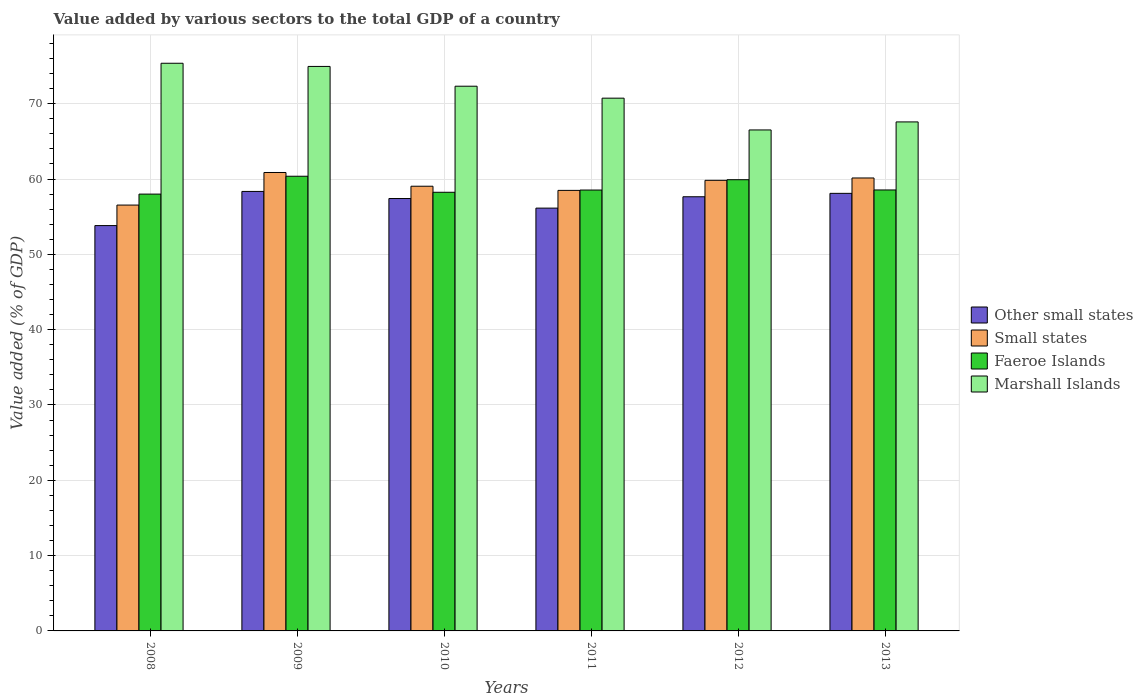How many groups of bars are there?
Ensure brevity in your answer.  6. Are the number of bars per tick equal to the number of legend labels?
Your response must be concise. Yes. Are the number of bars on each tick of the X-axis equal?
Keep it short and to the point. Yes. What is the label of the 1st group of bars from the left?
Ensure brevity in your answer.  2008. What is the value added by various sectors to the total GDP in Marshall Islands in 2008?
Your response must be concise. 75.37. Across all years, what is the maximum value added by various sectors to the total GDP in Marshall Islands?
Offer a very short reply. 75.37. Across all years, what is the minimum value added by various sectors to the total GDP in Small states?
Your response must be concise. 56.54. In which year was the value added by various sectors to the total GDP in Faeroe Islands maximum?
Make the answer very short. 2009. What is the total value added by various sectors to the total GDP in Marshall Islands in the graph?
Keep it short and to the point. 427.5. What is the difference between the value added by various sectors to the total GDP in Other small states in 2008 and that in 2009?
Make the answer very short. -4.54. What is the difference between the value added by various sectors to the total GDP in Marshall Islands in 2010 and the value added by various sectors to the total GDP in Small states in 2013?
Keep it short and to the point. 12.18. What is the average value added by various sectors to the total GDP in Faeroe Islands per year?
Keep it short and to the point. 58.94. In the year 2013, what is the difference between the value added by various sectors to the total GDP in Marshall Islands and value added by various sectors to the total GDP in Other small states?
Offer a terse response. 9.49. What is the ratio of the value added by various sectors to the total GDP in Faeroe Islands in 2012 to that in 2013?
Your answer should be compact. 1.02. Is the value added by various sectors to the total GDP in Other small states in 2010 less than that in 2012?
Give a very brief answer. Yes. Is the difference between the value added by various sectors to the total GDP in Marshall Islands in 2008 and 2011 greater than the difference between the value added by various sectors to the total GDP in Other small states in 2008 and 2011?
Provide a short and direct response. Yes. What is the difference between the highest and the second highest value added by various sectors to the total GDP in Faeroe Islands?
Provide a succinct answer. 0.46. What is the difference between the highest and the lowest value added by various sectors to the total GDP in Faeroe Islands?
Ensure brevity in your answer.  2.37. Is the sum of the value added by various sectors to the total GDP in Marshall Islands in 2012 and 2013 greater than the maximum value added by various sectors to the total GDP in Faeroe Islands across all years?
Provide a short and direct response. Yes. What does the 3rd bar from the left in 2011 represents?
Your answer should be compact. Faeroe Islands. What does the 4th bar from the right in 2013 represents?
Your answer should be compact. Other small states. Is it the case that in every year, the sum of the value added by various sectors to the total GDP in Marshall Islands and value added by various sectors to the total GDP in Small states is greater than the value added by various sectors to the total GDP in Faeroe Islands?
Offer a terse response. Yes. How many bars are there?
Give a very brief answer. 24. Are all the bars in the graph horizontal?
Offer a very short reply. No. How many years are there in the graph?
Offer a terse response. 6. What is the difference between two consecutive major ticks on the Y-axis?
Your answer should be compact. 10. Are the values on the major ticks of Y-axis written in scientific E-notation?
Your response must be concise. No. How are the legend labels stacked?
Give a very brief answer. Vertical. What is the title of the graph?
Offer a terse response. Value added by various sectors to the total GDP of a country. What is the label or title of the X-axis?
Your answer should be very brief. Years. What is the label or title of the Y-axis?
Offer a terse response. Value added (% of GDP). What is the Value added (% of GDP) in Other small states in 2008?
Your answer should be compact. 53.82. What is the Value added (% of GDP) in Small states in 2008?
Provide a short and direct response. 56.54. What is the Value added (% of GDP) of Faeroe Islands in 2008?
Offer a very short reply. 58. What is the Value added (% of GDP) of Marshall Islands in 2008?
Your response must be concise. 75.37. What is the Value added (% of GDP) in Other small states in 2009?
Make the answer very short. 58.36. What is the Value added (% of GDP) in Small states in 2009?
Keep it short and to the point. 60.87. What is the Value added (% of GDP) of Faeroe Islands in 2009?
Ensure brevity in your answer.  60.37. What is the Value added (% of GDP) in Marshall Islands in 2009?
Give a very brief answer. 74.95. What is the Value added (% of GDP) of Other small states in 2010?
Offer a terse response. 57.41. What is the Value added (% of GDP) in Small states in 2010?
Ensure brevity in your answer.  59.05. What is the Value added (% of GDP) in Faeroe Islands in 2010?
Provide a short and direct response. 58.24. What is the Value added (% of GDP) of Marshall Islands in 2010?
Give a very brief answer. 72.33. What is the Value added (% of GDP) of Other small states in 2011?
Provide a succinct answer. 56.14. What is the Value added (% of GDP) of Small states in 2011?
Keep it short and to the point. 58.49. What is the Value added (% of GDP) in Faeroe Islands in 2011?
Provide a succinct answer. 58.54. What is the Value added (% of GDP) of Marshall Islands in 2011?
Provide a short and direct response. 70.74. What is the Value added (% of GDP) in Other small states in 2012?
Make the answer very short. 57.65. What is the Value added (% of GDP) in Small states in 2012?
Make the answer very short. 59.83. What is the Value added (% of GDP) of Faeroe Islands in 2012?
Your answer should be very brief. 59.91. What is the Value added (% of GDP) in Marshall Islands in 2012?
Make the answer very short. 66.52. What is the Value added (% of GDP) in Other small states in 2013?
Your answer should be very brief. 58.1. What is the Value added (% of GDP) in Small states in 2013?
Make the answer very short. 60.14. What is the Value added (% of GDP) in Faeroe Islands in 2013?
Your answer should be compact. 58.55. What is the Value added (% of GDP) in Marshall Islands in 2013?
Provide a succinct answer. 67.59. Across all years, what is the maximum Value added (% of GDP) of Other small states?
Your answer should be compact. 58.36. Across all years, what is the maximum Value added (% of GDP) of Small states?
Offer a very short reply. 60.87. Across all years, what is the maximum Value added (% of GDP) in Faeroe Islands?
Give a very brief answer. 60.37. Across all years, what is the maximum Value added (% of GDP) of Marshall Islands?
Make the answer very short. 75.37. Across all years, what is the minimum Value added (% of GDP) of Other small states?
Your answer should be compact. 53.82. Across all years, what is the minimum Value added (% of GDP) in Small states?
Offer a very short reply. 56.54. Across all years, what is the minimum Value added (% of GDP) in Faeroe Islands?
Your response must be concise. 58. Across all years, what is the minimum Value added (% of GDP) in Marshall Islands?
Your response must be concise. 66.52. What is the total Value added (% of GDP) in Other small states in the graph?
Your answer should be very brief. 341.48. What is the total Value added (% of GDP) in Small states in the graph?
Offer a very short reply. 354.93. What is the total Value added (% of GDP) in Faeroe Islands in the graph?
Provide a succinct answer. 353.62. What is the total Value added (% of GDP) of Marshall Islands in the graph?
Give a very brief answer. 427.5. What is the difference between the Value added (% of GDP) of Other small states in 2008 and that in 2009?
Your answer should be very brief. -4.54. What is the difference between the Value added (% of GDP) of Small states in 2008 and that in 2009?
Make the answer very short. -4.33. What is the difference between the Value added (% of GDP) of Faeroe Islands in 2008 and that in 2009?
Offer a terse response. -2.37. What is the difference between the Value added (% of GDP) of Marshall Islands in 2008 and that in 2009?
Your answer should be compact. 0.42. What is the difference between the Value added (% of GDP) in Other small states in 2008 and that in 2010?
Your answer should be very brief. -3.59. What is the difference between the Value added (% of GDP) in Small states in 2008 and that in 2010?
Your response must be concise. -2.5. What is the difference between the Value added (% of GDP) in Faeroe Islands in 2008 and that in 2010?
Offer a terse response. -0.24. What is the difference between the Value added (% of GDP) of Marshall Islands in 2008 and that in 2010?
Make the answer very short. 3.05. What is the difference between the Value added (% of GDP) of Other small states in 2008 and that in 2011?
Keep it short and to the point. -2.32. What is the difference between the Value added (% of GDP) of Small states in 2008 and that in 2011?
Your answer should be compact. -1.95. What is the difference between the Value added (% of GDP) of Faeroe Islands in 2008 and that in 2011?
Keep it short and to the point. -0.54. What is the difference between the Value added (% of GDP) of Marshall Islands in 2008 and that in 2011?
Your response must be concise. 4.63. What is the difference between the Value added (% of GDP) in Other small states in 2008 and that in 2012?
Provide a short and direct response. -3.83. What is the difference between the Value added (% of GDP) in Small states in 2008 and that in 2012?
Ensure brevity in your answer.  -3.29. What is the difference between the Value added (% of GDP) of Faeroe Islands in 2008 and that in 2012?
Ensure brevity in your answer.  -1.91. What is the difference between the Value added (% of GDP) in Marshall Islands in 2008 and that in 2012?
Provide a short and direct response. 8.86. What is the difference between the Value added (% of GDP) of Other small states in 2008 and that in 2013?
Ensure brevity in your answer.  -4.28. What is the difference between the Value added (% of GDP) of Small states in 2008 and that in 2013?
Your answer should be very brief. -3.6. What is the difference between the Value added (% of GDP) in Faeroe Islands in 2008 and that in 2013?
Make the answer very short. -0.55. What is the difference between the Value added (% of GDP) of Marshall Islands in 2008 and that in 2013?
Provide a succinct answer. 7.79. What is the difference between the Value added (% of GDP) in Other small states in 2009 and that in 2010?
Offer a very short reply. 0.94. What is the difference between the Value added (% of GDP) in Small states in 2009 and that in 2010?
Offer a terse response. 1.82. What is the difference between the Value added (% of GDP) in Faeroe Islands in 2009 and that in 2010?
Offer a terse response. 2.13. What is the difference between the Value added (% of GDP) of Marshall Islands in 2009 and that in 2010?
Provide a succinct answer. 2.63. What is the difference between the Value added (% of GDP) of Other small states in 2009 and that in 2011?
Give a very brief answer. 2.21. What is the difference between the Value added (% of GDP) in Small states in 2009 and that in 2011?
Your response must be concise. 2.38. What is the difference between the Value added (% of GDP) in Faeroe Islands in 2009 and that in 2011?
Ensure brevity in your answer.  1.83. What is the difference between the Value added (% of GDP) in Marshall Islands in 2009 and that in 2011?
Your answer should be compact. 4.21. What is the difference between the Value added (% of GDP) in Other small states in 2009 and that in 2012?
Offer a terse response. 0.71. What is the difference between the Value added (% of GDP) of Small states in 2009 and that in 2012?
Your answer should be very brief. 1.04. What is the difference between the Value added (% of GDP) of Faeroe Islands in 2009 and that in 2012?
Your response must be concise. 0.46. What is the difference between the Value added (% of GDP) in Marshall Islands in 2009 and that in 2012?
Make the answer very short. 8.43. What is the difference between the Value added (% of GDP) in Other small states in 2009 and that in 2013?
Your answer should be very brief. 0.25. What is the difference between the Value added (% of GDP) in Small states in 2009 and that in 2013?
Offer a very short reply. 0.73. What is the difference between the Value added (% of GDP) of Faeroe Islands in 2009 and that in 2013?
Your answer should be compact. 1.82. What is the difference between the Value added (% of GDP) of Marshall Islands in 2009 and that in 2013?
Your answer should be very brief. 7.37. What is the difference between the Value added (% of GDP) of Other small states in 2010 and that in 2011?
Your answer should be compact. 1.27. What is the difference between the Value added (% of GDP) of Small states in 2010 and that in 2011?
Provide a succinct answer. 0.55. What is the difference between the Value added (% of GDP) in Faeroe Islands in 2010 and that in 2011?
Your answer should be very brief. -0.3. What is the difference between the Value added (% of GDP) of Marshall Islands in 2010 and that in 2011?
Your answer should be very brief. 1.59. What is the difference between the Value added (% of GDP) in Other small states in 2010 and that in 2012?
Offer a terse response. -0.23. What is the difference between the Value added (% of GDP) of Small states in 2010 and that in 2012?
Ensure brevity in your answer.  -0.78. What is the difference between the Value added (% of GDP) in Faeroe Islands in 2010 and that in 2012?
Provide a short and direct response. -1.67. What is the difference between the Value added (% of GDP) of Marshall Islands in 2010 and that in 2012?
Offer a very short reply. 5.81. What is the difference between the Value added (% of GDP) of Other small states in 2010 and that in 2013?
Keep it short and to the point. -0.69. What is the difference between the Value added (% of GDP) of Small states in 2010 and that in 2013?
Ensure brevity in your answer.  -1.1. What is the difference between the Value added (% of GDP) of Faeroe Islands in 2010 and that in 2013?
Make the answer very short. -0.31. What is the difference between the Value added (% of GDP) of Marshall Islands in 2010 and that in 2013?
Offer a very short reply. 4.74. What is the difference between the Value added (% of GDP) of Other small states in 2011 and that in 2012?
Provide a succinct answer. -1.51. What is the difference between the Value added (% of GDP) in Small states in 2011 and that in 2012?
Keep it short and to the point. -1.34. What is the difference between the Value added (% of GDP) in Faeroe Islands in 2011 and that in 2012?
Provide a succinct answer. -1.37. What is the difference between the Value added (% of GDP) in Marshall Islands in 2011 and that in 2012?
Provide a succinct answer. 4.22. What is the difference between the Value added (% of GDP) of Other small states in 2011 and that in 2013?
Your answer should be very brief. -1.96. What is the difference between the Value added (% of GDP) in Small states in 2011 and that in 2013?
Ensure brevity in your answer.  -1.65. What is the difference between the Value added (% of GDP) of Faeroe Islands in 2011 and that in 2013?
Your answer should be compact. -0.01. What is the difference between the Value added (% of GDP) of Marshall Islands in 2011 and that in 2013?
Your answer should be compact. 3.15. What is the difference between the Value added (% of GDP) in Other small states in 2012 and that in 2013?
Your answer should be compact. -0.45. What is the difference between the Value added (% of GDP) of Small states in 2012 and that in 2013?
Your answer should be very brief. -0.31. What is the difference between the Value added (% of GDP) of Faeroe Islands in 2012 and that in 2013?
Offer a terse response. 1.36. What is the difference between the Value added (% of GDP) in Marshall Islands in 2012 and that in 2013?
Give a very brief answer. -1.07. What is the difference between the Value added (% of GDP) in Other small states in 2008 and the Value added (% of GDP) in Small states in 2009?
Keep it short and to the point. -7.05. What is the difference between the Value added (% of GDP) of Other small states in 2008 and the Value added (% of GDP) of Faeroe Islands in 2009?
Provide a short and direct response. -6.55. What is the difference between the Value added (% of GDP) in Other small states in 2008 and the Value added (% of GDP) in Marshall Islands in 2009?
Provide a short and direct response. -21.13. What is the difference between the Value added (% of GDP) in Small states in 2008 and the Value added (% of GDP) in Faeroe Islands in 2009?
Ensure brevity in your answer.  -3.83. What is the difference between the Value added (% of GDP) in Small states in 2008 and the Value added (% of GDP) in Marshall Islands in 2009?
Offer a terse response. -18.41. What is the difference between the Value added (% of GDP) in Faeroe Islands in 2008 and the Value added (% of GDP) in Marshall Islands in 2009?
Provide a short and direct response. -16.95. What is the difference between the Value added (% of GDP) of Other small states in 2008 and the Value added (% of GDP) of Small states in 2010?
Give a very brief answer. -5.23. What is the difference between the Value added (% of GDP) of Other small states in 2008 and the Value added (% of GDP) of Faeroe Islands in 2010?
Keep it short and to the point. -4.42. What is the difference between the Value added (% of GDP) in Other small states in 2008 and the Value added (% of GDP) in Marshall Islands in 2010?
Offer a very short reply. -18.51. What is the difference between the Value added (% of GDP) in Small states in 2008 and the Value added (% of GDP) in Faeroe Islands in 2010?
Give a very brief answer. -1.7. What is the difference between the Value added (% of GDP) of Small states in 2008 and the Value added (% of GDP) of Marshall Islands in 2010?
Offer a terse response. -15.78. What is the difference between the Value added (% of GDP) of Faeroe Islands in 2008 and the Value added (% of GDP) of Marshall Islands in 2010?
Keep it short and to the point. -14.32. What is the difference between the Value added (% of GDP) of Other small states in 2008 and the Value added (% of GDP) of Small states in 2011?
Offer a very short reply. -4.67. What is the difference between the Value added (% of GDP) of Other small states in 2008 and the Value added (% of GDP) of Faeroe Islands in 2011?
Offer a terse response. -4.72. What is the difference between the Value added (% of GDP) of Other small states in 2008 and the Value added (% of GDP) of Marshall Islands in 2011?
Your answer should be very brief. -16.92. What is the difference between the Value added (% of GDP) of Small states in 2008 and the Value added (% of GDP) of Faeroe Islands in 2011?
Give a very brief answer. -2. What is the difference between the Value added (% of GDP) in Small states in 2008 and the Value added (% of GDP) in Marshall Islands in 2011?
Keep it short and to the point. -14.2. What is the difference between the Value added (% of GDP) in Faeroe Islands in 2008 and the Value added (% of GDP) in Marshall Islands in 2011?
Ensure brevity in your answer.  -12.74. What is the difference between the Value added (% of GDP) in Other small states in 2008 and the Value added (% of GDP) in Small states in 2012?
Provide a succinct answer. -6.01. What is the difference between the Value added (% of GDP) of Other small states in 2008 and the Value added (% of GDP) of Faeroe Islands in 2012?
Give a very brief answer. -6.09. What is the difference between the Value added (% of GDP) in Other small states in 2008 and the Value added (% of GDP) in Marshall Islands in 2012?
Give a very brief answer. -12.7. What is the difference between the Value added (% of GDP) in Small states in 2008 and the Value added (% of GDP) in Faeroe Islands in 2012?
Your answer should be compact. -3.37. What is the difference between the Value added (% of GDP) in Small states in 2008 and the Value added (% of GDP) in Marshall Islands in 2012?
Keep it short and to the point. -9.98. What is the difference between the Value added (% of GDP) of Faeroe Islands in 2008 and the Value added (% of GDP) of Marshall Islands in 2012?
Offer a terse response. -8.52. What is the difference between the Value added (% of GDP) of Other small states in 2008 and the Value added (% of GDP) of Small states in 2013?
Your answer should be very brief. -6.32. What is the difference between the Value added (% of GDP) in Other small states in 2008 and the Value added (% of GDP) in Faeroe Islands in 2013?
Provide a short and direct response. -4.73. What is the difference between the Value added (% of GDP) of Other small states in 2008 and the Value added (% of GDP) of Marshall Islands in 2013?
Provide a succinct answer. -13.77. What is the difference between the Value added (% of GDP) in Small states in 2008 and the Value added (% of GDP) in Faeroe Islands in 2013?
Make the answer very short. -2.01. What is the difference between the Value added (% of GDP) of Small states in 2008 and the Value added (% of GDP) of Marshall Islands in 2013?
Make the answer very short. -11.04. What is the difference between the Value added (% of GDP) in Faeroe Islands in 2008 and the Value added (% of GDP) in Marshall Islands in 2013?
Provide a succinct answer. -9.58. What is the difference between the Value added (% of GDP) of Other small states in 2009 and the Value added (% of GDP) of Small states in 2010?
Keep it short and to the point. -0.69. What is the difference between the Value added (% of GDP) of Other small states in 2009 and the Value added (% of GDP) of Faeroe Islands in 2010?
Offer a terse response. 0.11. What is the difference between the Value added (% of GDP) of Other small states in 2009 and the Value added (% of GDP) of Marshall Islands in 2010?
Offer a very short reply. -13.97. What is the difference between the Value added (% of GDP) in Small states in 2009 and the Value added (% of GDP) in Faeroe Islands in 2010?
Keep it short and to the point. 2.63. What is the difference between the Value added (% of GDP) of Small states in 2009 and the Value added (% of GDP) of Marshall Islands in 2010?
Offer a terse response. -11.46. What is the difference between the Value added (% of GDP) of Faeroe Islands in 2009 and the Value added (% of GDP) of Marshall Islands in 2010?
Your answer should be very brief. -11.96. What is the difference between the Value added (% of GDP) of Other small states in 2009 and the Value added (% of GDP) of Small states in 2011?
Provide a short and direct response. -0.14. What is the difference between the Value added (% of GDP) of Other small states in 2009 and the Value added (% of GDP) of Faeroe Islands in 2011?
Keep it short and to the point. -0.19. What is the difference between the Value added (% of GDP) in Other small states in 2009 and the Value added (% of GDP) in Marshall Islands in 2011?
Offer a terse response. -12.38. What is the difference between the Value added (% of GDP) of Small states in 2009 and the Value added (% of GDP) of Faeroe Islands in 2011?
Your answer should be compact. 2.33. What is the difference between the Value added (% of GDP) in Small states in 2009 and the Value added (% of GDP) in Marshall Islands in 2011?
Your answer should be very brief. -9.87. What is the difference between the Value added (% of GDP) of Faeroe Islands in 2009 and the Value added (% of GDP) of Marshall Islands in 2011?
Ensure brevity in your answer.  -10.37. What is the difference between the Value added (% of GDP) in Other small states in 2009 and the Value added (% of GDP) in Small states in 2012?
Provide a short and direct response. -1.47. What is the difference between the Value added (% of GDP) in Other small states in 2009 and the Value added (% of GDP) in Faeroe Islands in 2012?
Keep it short and to the point. -1.56. What is the difference between the Value added (% of GDP) in Other small states in 2009 and the Value added (% of GDP) in Marshall Islands in 2012?
Offer a terse response. -8.16. What is the difference between the Value added (% of GDP) in Small states in 2009 and the Value added (% of GDP) in Faeroe Islands in 2012?
Keep it short and to the point. 0.96. What is the difference between the Value added (% of GDP) in Small states in 2009 and the Value added (% of GDP) in Marshall Islands in 2012?
Your answer should be compact. -5.65. What is the difference between the Value added (% of GDP) of Faeroe Islands in 2009 and the Value added (% of GDP) of Marshall Islands in 2012?
Offer a terse response. -6.15. What is the difference between the Value added (% of GDP) of Other small states in 2009 and the Value added (% of GDP) of Small states in 2013?
Your answer should be very brief. -1.79. What is the difference between the Value added (% of GDP) in Other small states in 2009 and the Value added (% of GDP) in Faeroe Islands in 2013?
Give a very brief answer. -0.19. What is the difference between the Value added (% of GDP) of Other small states in 2009 and the Value added (% of GDP) of Marshall Islands in 2013?
Offer a terse response. -9.23. What is the difference between the Value added (% of GDP) of Small states in 2009 and the Value added (% of GDP) of Faeroe Islands in 2013?
Ensure brevity in your answer.  2.32. What is the difference between the Value added (% of GDP) of Small states in 2009 and the Value added (% of GDP) of Marshall Islands in 2013?
Provide a succinct answer. -6.72. What is the difference between the Value added (% of GDP) of Faeroe Islands in 2009 and the Value added (% of GDP) of Marshall Islands in 2013?
Your response must be concise. -7.21. What is the difference between the Value added (% of GDP) in Other small states in 2010 and the Value added (% of GDP) in Small states in 2011?
Provide a succinct answer. -1.08. What is the difference between the Value added (% of GDP) in Other small states in 2010 and the Value added (% of GDP) in Faeroe Islands in 2011?
Your answer should be very brief. -1.13. What is the difference between the Value added (% of GDP) in Other small states in 2010 and the Value added (% of GDP) in Marshall Islands in 2011?
Ensure brevity in your answer.  -13.33. What is the difference between the Value added (% of GDP) of Small states in 2010 and the Value added (% of GDP) of Faeroe Islands in 2011?
Your answer should be compact. 0.51. What is the difference between the Value added (% of GDP) of Small states in 2010 and the Value added (% of GDP) of Marshall Islands in 2011?
Make the answer very short. -11.69. What is the difference between the Value added (% of GDP) of Faeroe Islands in 2010 and the Value added (% of GDP) of Marshall Islands in 2011?
Offer a very short reply. -12.5. What is the difference between the Value added (% of GDP) in Other small states in 2010 and the Value added (% of GDP) in Small states in 2012?
Your answer should be compact. -2.42. What is the difference between the Value added (% of GDP) in Other small states in 2010 and the Value added (% of GDP) in Faeroe Islands in 2012?
Your response must be concise. -2.5. What is the difference between the Value added (% of GDP) in Other small states in 2010 and the Value added (% of GDP) in Marshall Islands in 2012?
Your answer should be compact. -9.11. What is the difference between the Value added (% of GDP) of Small states in 2010 and the Value added (% of GDP) of Faeroe Islands in 2012?
Provide a succinct answer. -0.87. What is the difference between the Value added (% of GDP) of Small states in 2010 and the Value added (% of GDP) of Marshall Islands in 2012?
Provide a short and direct response. -7.47. What is the difference between the Value added (% of GDP) in Faeroe Islands in 2010 and the Value added (% of GDP) in Marshall Islands in 2012?
Offer a terse response. -8.28. What is the difference between the Value added (% of GDP) in Other small states in 2010 and the Value added (% of GDP) in Small states in 2013?
Ensure brevity in your answer.  -2.73. What is the difference between the Value added (% of GDP) of Other small states in 2010 and the Value added (% of GDP) of Faeroe Islands in 2013?
Provide a succinct answer. -1.14. What is the difference between the Value added (% of GDP) of Other small states in 2010 and the Value added (% of GDP) of Marshall Islands in 2013?
Give a very brief answer. -10.17. What is the difference between the Value added (% of GDP) in Small states in 2010 and the Value added (% of GDP) in Faeroe Islands in 2013?
Provide a succinct answer. 0.5. What is the difference between the Value added (% of GDP) of Small states in 2010 and the Value added (% of GDP) of Marshall Islands in 2013?
Ensure brevity in your answer.  -8.54. What is the difference between the Value added (% of GDP) of Faeroe Islands in 2010 and the Value added (% of GDP) of Marshall Islands in 2013?
Your answer should be compact. -9.34. What is the difference between the Value added (% of GDP) in Other small states in 2011 and the Value added (% of GDP) in Small states in 2012?
Your answer should be very brief. -3.69. What is the difference between the Value added (% of GDP) in Other small states in 2011 and the Value added (% of GDP) in Faeroe Islands in 2012?
Provide a short and direct response. -3.77. What is the difference between the Value added (% of GDP) of Other small states in 2011 and the Value added (% of GDP) of Marshall Islands in 2012?
Provide a succinct answer. -10.38. What is the difference between the Value added (% of GDP) of Small states in 2011 and the Value added (% of GDP) of Faeroe Islands in 2012?
Your answer should be very brief. -1.42. What is the difference between the Value added (% of GDP) in Small states in 2011 and the Value added (% of GDP) in Marshall Islands in 2012?
Provide a succinct answer. -8.02. What is the difference between the Value added (% of GDP) of Faeroe Islands in 2011 and the Value added (% of GDP) of Marshall Islands in 2012?
Provide a succinct answer. -7.98. What is the difference between the Value added (% of GDP) of Other small states in 2011 and the Value added (% of GDP) of Small states in 2013?
Your response must be concise. -4. What is the difference between the Value added (% of GDP) of Other small states in 2011 and the Value added (% of GDP) of Faeroe Islands in 2013?
Ensure brevity in your answer.  -2.41. What is the difference between the Value added (% of GDP) in Other small states in 2011 and the Value added (% of GDP) in Marshall Islands in 2013?
Give a very brief answer. -11.45. What is the difference between the Value added (% of GDP) of Small states in 2011 and the Value added (% of GDP) of Faeroe Islands in 2013?
Give a very brief answer. -0.06. What is the difference between the Value added (% of GDP) of Small states in 2011 and the Value added (% of GDP) of Marshall Islands in 2013?
Ensure brevity in your answer.  -9.09. What is the difference between the Value added (% of GDP) of Faeroe Islands in 2011 and the Value added (% of GDP) of Marshall Islands in 2013?
Provide a short and direct response. -9.05. What is the difference between the Value added (% of GDP) of Other small states in 2012 and the Value added (% of GDP) of Small states in 2013?
Make the answer very short. -2.49. What is the difference between the Value added (% of GDP) of Other small states in 2012 and the Value added (% of GDP) of Faeroe Islands in 2013?
Keep it short and to the point. -0.9. What is the difference between the Value added (% of GDP) in Other small states in 2012 and the Value added (% of GDP) in Marshall Islands in 2013?
Your answer should be compact. -9.94. What is the difference between the Value added (% of GDP) of Small states in 2012 and the Value added (% of GDP) of Faeroe Islands in 2013?
Provide a short and direct response. 1.28. What is the difference between the Value added (% of GDP) of Small states in 2012 and the Value added (% of GDP) of Marshall Islands in 2013?
Your response must be concise. -7.76. What is the difference between the Value added (% of GDP) in Faeroe Islands in 2012 and the Value added (% of GDP) in Marshall Islands in 2013?
Offer a terse response. -7.67. What is the average Value added (% of GDP) in Other small states per year?
Give a very brief answer. 56.91. What is the average Value added (% of GDP) of Small states per year?
Make the answer very short. 59.15. What is the average Value added (% of GDP) in Faeroe Islands per year?
Give a very brief answer. 58.94. What is the average Value added (% of GDP) of Marshall Islands per year?
Your answer should be very brief. 71.25. In the year 2008, what is the difference between the Value added (% of GDP) of Other small states and Value added (% of GDP) of Small states?
Offer a very short reply. -2.72. In the year 2008, what is the difference between the Value added (% of GDP) of Other small states and Value added (% of GDP) of Faeroe Islands?
Provide a succinct answer. -4.18. In the year 2008, what is the difference between the Value added (% of GDP) of Other small states and Value added (% of GDP) of Marshall Islands?
Your response must be concise. -21.55. In the year 2008, what is the difference between the Value added (% of GDP) of Small states and Value added (% of GDP) of Faeroe Islands?
Make the answer very short. -1.46. In the year 2008, what is the difference between the Value added (% of GDP) in Small states and Value added (% of GDP) in Marshall Islands?
Make the answer very short. -18.83. In the year 2008, what is the difference between the Value added (% of GDP) in Faeroe Islands and Value added (% of GDP) in Marshall Islands?
Your answer should be compact. -17.37. In the year 2009, what is the difference between the Value added (% of GDP) of Other small states and Value added (% of GDP) of Small states?
Your response must be concise. -2.51. In the year 2009, what is the difference between the Value added (% of GDP) in Other small states and Value added (% of GDP) in Faeroe Islands?
Give a very brief answer. -2.02. In the year 2009, what is the difference between the Value added (% of GDP) in Other small states and Value added (% of GDP) in Marshall Islands?
Make the answer very short. -16.6. In the year 2009, what is the difference between the Value added (% of GDP) of Small states and Value added (% of GDP) of Faeroe Islands?
Give a very brief answer. 0.5. In the year 2009, what is the difference between the Value added (% of GDP) of Small states and Value added (% of GDP) of Marshall Islands?
Give a very brief answer. -14.08. In the year 2009, what is the difference between the Value added (% of GDP) in Faeroe Islands and Value added (% of GDP) in Marshall Islands?
Keep it short and to the point. -14.58. In the year 2010, what is the difference between the Value added (% of GDP) of Other small states and Value added (% of GDP) of Small states?
Your answer should be very brief. -1.63. In the year 2010, what is the difference between the Value added (% of GDP) of Other small states and Value added (% of GDP) of Faeroe Islands?
Provide a short and direct response. -0.83. In the year 2010, what is the difference between the Value added (% of GDP) of Other small states and Value added (% of GDP) of Marshall Islands?
Ensure brevity in your answer.  -14.91. In the year 2010, what is the difference between the Value added (% of GDP) in Small states and Value added (% of GDP) in Faeroe Islands?
Keep it short and to the point. 0.8. In the year 2010, what is the difference between the Value added (% of GDP) of Small states and Value added (% of GDP) of Marshall Islands?
Your response must be concise. -13.28. In the year 2010, what is the difference between the Value added (% of GDP) in Faeroe Islands and Value added (% of GDP) in Marshall Islands?
Provide a short and direct response. -14.08. In the year 2011, what is the difference between the Value added (% of GDP) in Other small states and Value added (% of GDP) in Small states?
Your response must be concise. -2.35. In the year 2011, what is the difference between the Value added (% of GDP) of Other small states and Value added (% of GDP) of Faeroe Islands?
Keep it short and to the point. -2.4. In the year 2011, what is the difference between the Value added (% of GDP) of Other small states and Value added (% of GDP) of Marshall Islands?
Keep it short and to the point. -14.6. In the year 2011, what is the difference between the Value added (% of GDP) of Small states and Value added (% of GDP) of Faeroe Islands?
Offer a very short reply. -0.05. In the year 2011, what is the difference between the Value added (% of GDP) of Small states and Value added (% of GDP) of Marshall Islands?
Your response must be concise. -12.24. In the year 2011, what is the difference between the Value added (% of GDP) in Faeroe Islands and Value added (% of GDP) in Marshall Islands?
Offer a very short reply. -12.2. In the year 2012, what is the difference between the Value added (% of GDP) of Other small states and Value added (% of GDP) of Small states?
Give a very brief answer. -2.18. In the year 2012, what is the difference between the Value added (% of GDP) of Other small states and Value added (% of GDP) of Faeroe Islands?
Ensure brevity in your answer.  -2.26. In the year 2012, what is the difference between the Value added (% of GDP) of Other small states and Value added (% of GDP) of Marshall Islands?
Make the answer very short. -8.87. In the year 2012, what is the difference between the Value added (% of GDP) in Small states and Value added (% of GDP) in Faeroe Islands?
Keep it short and to the point. -0.08. In the year 2012, what is the difference between the Value added (% of GDP) in Small states and Value added (% of GDP) in Marshall Islands?
Make the answer very short. -6.69. In the year 2012, what is the difference between the Value added (% of GDP) in Faeroe Islands and Value added (% of GDP) in Marshall Islands?
Your response must be concise. -6.61. In the year 2013, what is the difference between the Value added (% of GDP) of Other small states and Value added (% of GDP) of Small states?
Your answer should be very brief. -2.04. In the year 2013, what is the difference between the Value added (% of GDP) of Other small states and Value added (% of GDP) of Faeroe Islands?
Make the answer very short. -0.45. In the year 2013, what is the difference between the Value added (% of GDP) in Other small states and Value added (% of GDP) in Marshall Islands?
Keep it short and to the point. -9.49. In the year 2013, what is the difference between the Value added (% of GDP) of Small states and Value added (% of GDP) of Faeroe Islands?
Ensure brevity in your answer.  1.59. In the year 2013, what is the difference between the Value added (% of GDP) in Small states and Value added (% of GDP) in Marshall Islands?
Give a very brief answer. -7.44. In the year 2013, what is the difference between the Value added (% of GDP) in Faeroe Islands and Value added (% of GDP) in Marshall Islands?
Your answer should be very brief. -9.04. What is the ratio of the Value added (% of GDP) in Other small states in 2008 to that in 2009?
Keep it short and to the point. 0.92. What is the ratio of the Value added (% of GDP) of Small states in 2008 to that in 2009?
Offer a terse response. 0.93. What is the ratio of the Value added (% of GDP) in Faeroe Islands in 2008 to that in 2009?
Offer a terse response. 0.96. What is the ratio of the Value added (% of GDP) in Marshall Islands in 2008 to that in 2009?
Your response must be concise. 1.01. What is the ratio of the Value added (% of GDP) in Other small states in 2008 to that in 2010?
Your answer should be compact. 0.94. What is the ratio of the Value added (% of GDP) of Small states in 2008 to that in 2010?
Your answer should be compact. 0.96. What is the ratio of the Value added (% of GDP) in Faeroe Islands in 2008 to that in 2010?
Provide a short and direct response. 1. What is the ratio of the Value added (% of GDP) of Marshall Islands in 2008 to that in 2010?
Your response must be concise. 1.04. What is the ratio of the Value added (% of GDP) in Other small states in 2008 to that in 2011?
Your response must be concise. 0.96. What is the ratio of the Value added (% of GDP) of Small states in 2008 to that in 2011?
Provide a succinct answer. 0.97. What is the ratio of the Value added (% of GDP) in Marshall Islands in 2008 to that in 2011?
Give a very brief answer. 1.07. What is the ratio of the Value added (% of GDP) in Other small states in 2008 to that in 2012?
Give a very brief answer. 0.93. What is the ratio of the Value added (% of GDP) of Small states in 2008 to that in 2012?
Offer a very short reply. 0.95. What is the ratio of the Value added (% of GDP) of Faeroe Islands in 2008 to that in 2012?
Your answer should be very brief. 0.97. What is the ratio of the Value added (% of GDP) of Marshall Islands in 2008 to that in 2012?
Your answer should be very brief. 1.13. What is the ratio of the Value added (% of GDP) of Other small states in 2008 to that in 2013?
Provide a short and direct response. 0.93. What is the ratio of the Value added (% of GDP) in Small states in 2008 to that in 2013?
Your response must be concise. 0.94. What is the ratio of the Value added (% of GDP) in Faeroe Islands in 2008 to that in 2013?
Ensure brevity in your answer.  0.99. What is the ratio of the Value added (% of GDP) in Marshall Islands in 2008 to that in 2013?
Ensure brevity in your answer.  1.12. What is the ratio of the Value added (% of GDP) of Other small states in 2009 to that in 2010?
Keep it short and to the point. 1.02. What is the ratio of the Value added (% of GDP) of Small states in 2009 to that in 2010?
Your answer should be compact. 1.03. What is the ratio of the Value added (% of GDP) of Faeroe Islands in 2009 to that in 2010?
Your answer should be compact. 1.04. What is the ratio of the Value added (% of GDP) in Marshall Islands in 2009 to that in 2010?
Ensure brevity in your answer.  1.04. What is the ratio of the Value added (% of GDP) of Other small states in 2009 to that in 2011?
Your answer should be very brief. 1.04. What is the ratio of the Value added (% of GDP) of Small states in 2009 to that in 2011?
Make the answer very short. 1.04. What is the ratio of the Value added (% of GDP) of Faeroe Islands in 2009 to that in 2011?
Offer a very short reply. 1.03. What is the ratio of the Value added (% of GDP) of Marshall Islands in 2009 to that in 2011?
Keep it short and to the point. 1.06. What is the ratio of the Value added (% of GDP) in Other small states in 2009 to that in 2012?
Your answer should be compact. 1.01. What is the ratio of the Value added (% of GDP) of Small states in 2009 to that in 2012?
Your answer should be very brief. 1.02. What is the ratio of the Value added (% of GDP) of Faeroe Islands in 2009 to that in 2012?
Keep it short and to the point. 1.01. What is the ratio of the Value added (% of GDP) of Marshall Islands in 2009 to that in 2012?
Provide a succinct answer. 1.13. What is the ratio of the Value added (% of GDP) in Other small states in 2009 to that in 2013?
Offer a terse response. 1. What is the ratio of the Value added (% of GDP) in Small states in 2009 to that in 2013?
Your answer should be compact. 1.01. What is the ratio of the Value added (% of GDP) of Faeroe Islands in 2009 to that in 2013?
Provide a succinct answer. 1.03. What is the ratio of the Value added (% of GDP) in Marshall Islands in 2009 to that in 2013?
Your answer should be very brief. 1.11. What is the ratio of the Value added (% of GDP) of Other small states in 2010 to that in 2011?
Ensure brevity in your answer.  1.02. What is the ratio of the Value added (% of GDP) of Small states in 2010 to that in 2011?
Offer a very short reply. 1.01. What is the ratio of the Value added (% of GDP) of Marshall Islands in 2010 to that in 2011?
Offer a very short reply. 1.02. What is the ratio of the Value added (% of GDP) of Other small states in 2010 to that in 2012?
Give a very brief answer. 1. What is the ratio of the Value added (% of GDP) in Small states in 2010 to that in 2012?
Make the answer very short. 0.99. What is the ratio of the Value added (% of GDP) in Faeroe Islands in 2010 to that in 2012?
Your response must be concise. 0.97. What is the ratio of the Value added (% of GDP) in Marshall Islands in 2010 to that in 2012?
Keep it short and to the point. 1.09. What is the ratio of the Value added (% of GDP) in Small states in 2010 to that in 2013?
Your answer should be compact. 0.98. What is the ratio of the Value added (% of GDP) in Marshall Islands in 2010 to that in 2013?
Make the answer very short. 1.07. What is the ratio of the Value added (% of GDP) of Other small states in 2011 to that in 2012?
Keep it short and to the point. 0.97. What is the ratio of the Value added (% of GDP) of Small states in 2011 to that in 2012?
Provide a short and direct response. 0.98. What is the ratio of the Value added (% of GDP) of Faeroe Islands in 2011 to that in 2012?
Give a very brief answer. 0.98. What is the ratio of the Value added (% of GDP) of Marshall Islands in 2011 to that in 2012?
Give a very brief answer. 1.06. What is the ratio of the Value added (% of GDP) in Other small states in 2011 to that in 2013?
Provide a short and direct response. 0.97. What is the ratio of the Value added (% of GDP) in Small states in 2011 to that in 2013?
Provide a succinct answer. 0.97. What is the ratio of the Value added (% of GDP) in Faeroe Islands in 2011 to that in 2013?
Your response must be concise. 1. What is the ratio of the Value added (% of GDP) in Marshall Islands in 2011 to that in 2013?
Your response must be concise. 1.05. What is the ratio of the Value added (% of GDP) of Faeroe Islands in 2012 to that in 2013?
Offer a very short reply. 1.02. What is the ratio of the Value added (% of GDP) in Marshall Islands in 2012 to that in 2013?
Provide a short and direct response. 0.98. What is the difference between the highest and the second highest Value added (% of GDP) in Other small states?
Your answer should be very brief. 0.25. What is the difference between the highest and the second highest Value added (% of GDP) in Small states?
Your answer should be very brief. 0.73. What is the difference between the highest and the second highest Value added (% of GDP) of Faeroe Islands?
Your answer should be compact. 0.46. What is the difference between the highest and the second highest Value added (% of GDP) in Marshall Islands?
Offer a very short reply. 0.42. What is the difference between the highest and the lowest Value added (% of GDP) in Other small states?
Keep it short and to the point. 4.54. What is the difference between the highest and the lowest Value added (% of GDP) in Small states?
Offer a terse response. 4.33. What is the difference between the highest and the lowest Value added (% of GDP) of Faeroe Islands?
Ensure brevity in your answer.  2.37. What is the difference between the highest and the lowest Value added (% of GDP) of Marshall Islands?
Make the answer very short. 8.86. 